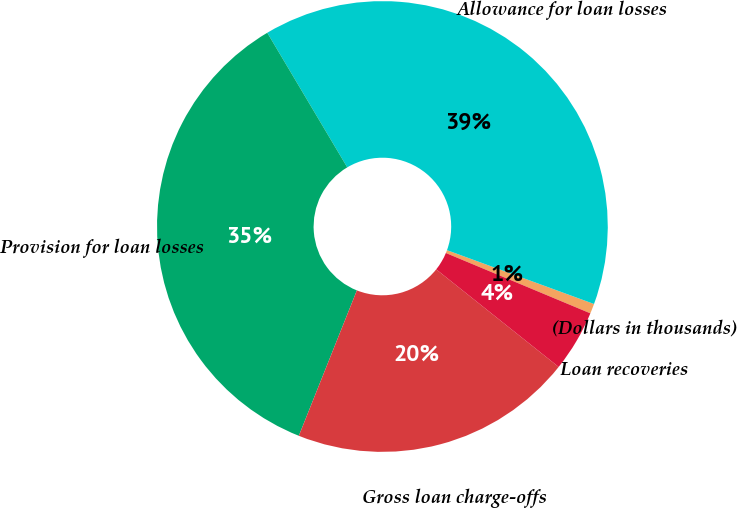Convert chart to OTSL. <chart><loc_0><loc_0><loc_500><loc_500><pie_chart><fcel>(Dollars in thousands)<fcel>Allowance for loan losses<fcel>Provision for loan losses<fcel>Gross loan charge-offs<fcel>Loan recoveries<nl><fcel>0.71%<fcel>39.12%<fcel>35.42%<fcel>20.34%<fcel>4.41%<nl></chart> 